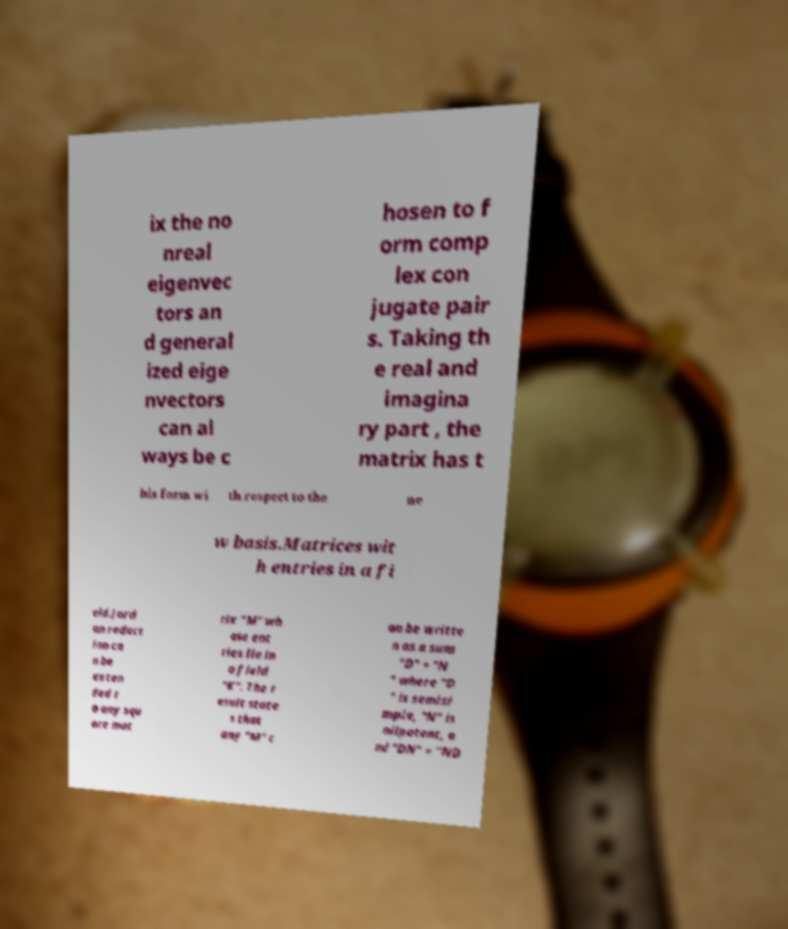Could you extract and type out the text from this image? ix the no nreal eigenvec tors an d general ized eige nvectors can al ways be c hosen to f orm comp lex con jugate pair s. Taking th e real and imagina ry part , the matrix has t his form wi th respect to the ne w basis.Matrices wit h entries in a fi eld.Jord an reduct ion ca n be exten ded t o any squ are mat rix "M" wh ose ent ries lie in a field "K". The r esult state s that any "M" c an be writte n as a sum "D" + "N " where "D " is semisi mple, "N" is nilpotent, a nd "DN" = "ND 